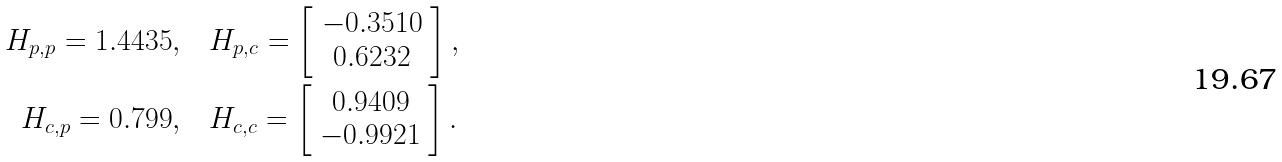Convert formula to latex. <formula><loc_0><loc_0><loc_500><loc_500>H _ { p , p } = 1 . 4 4 3 5 , & \quad H _ { p , c } = \left [ \begin{array} { c } - 0 . 3 5 1 0 \\ 0 . 6 2 3 2 \end{array} \right ] , \\ H _ { c , p } = 0 . 7 9 9 , & \quad H _ { c , c } = \left [ \begin{array} { c } 0 . 9 4 0 9 \\ - 0 . 9 9 2 1 \end{array} \right ] .</formula> 